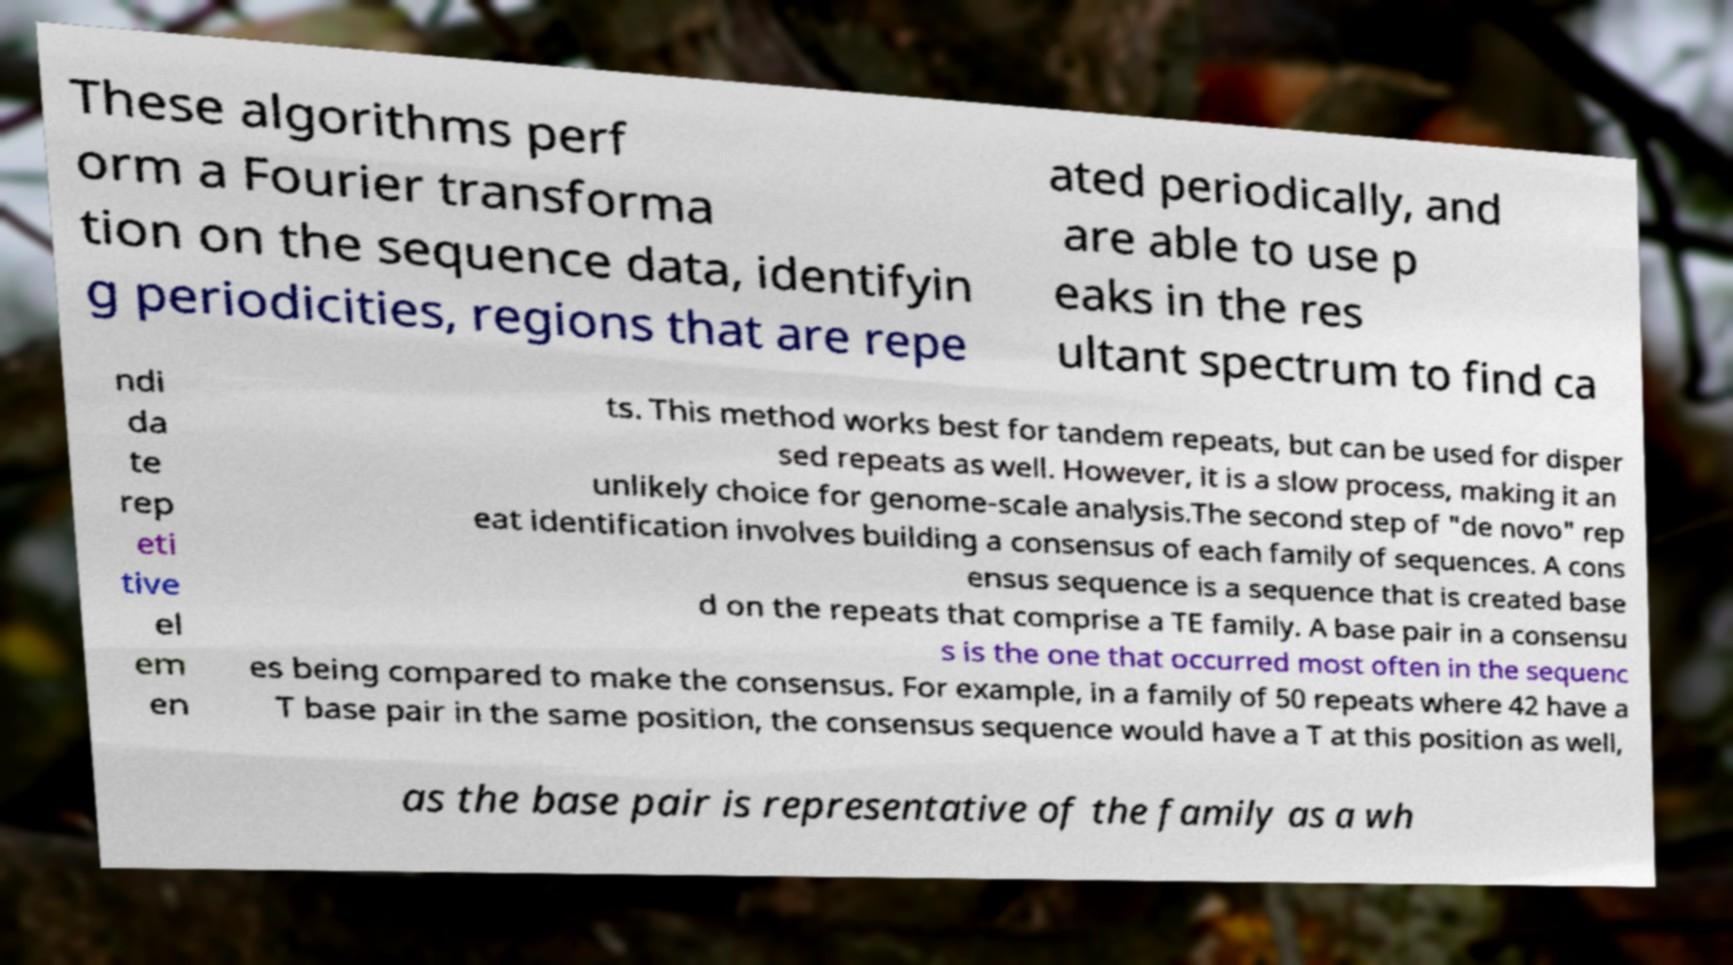I need the written content from this picture converted into text. Can you do that? These algorithms perf orm a Fourier transforma tion on the sequence data, identifyin g periodicities, regions that are repe ated periodically, and are able to use p eaks in the res ultant spectrum to find ca ndi da te rep eti tive el em en ts. This method works best for tandem repeats, but can be used for disper sed repeats as well. However, it is a slow process, making it an unlikely choice for genome-scale analysis.The second step of "de novo" rep eat identification involves building a consensus of each family of sequences. A cons ensus sequence is a sequence that is created base d on the repeats that comprise a TE family. A base pair in a consensu s is the one that occurred most often in the sequenc es being compared to make the consensus. For example, in a family of 50 repeats where 42 have a T base pair in the same position, the consensus sequence would have a T at this position as well, as the base pair is representative of the family as a wh 